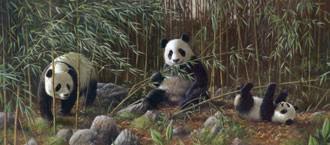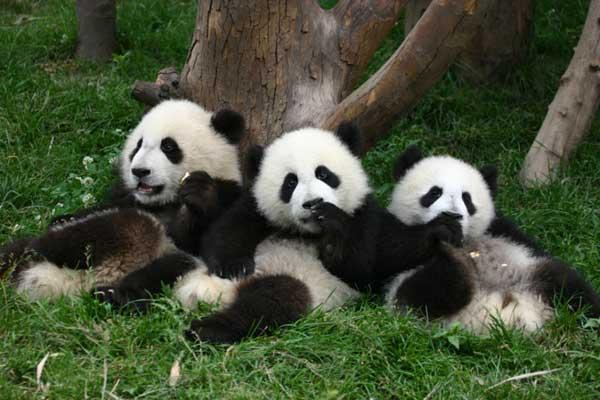The first image is the image on the left, the second image is the image on the right. Given the left and right images, does the statement "There is no more than one panda in the right image." hold true? Answer yes or no. No. 